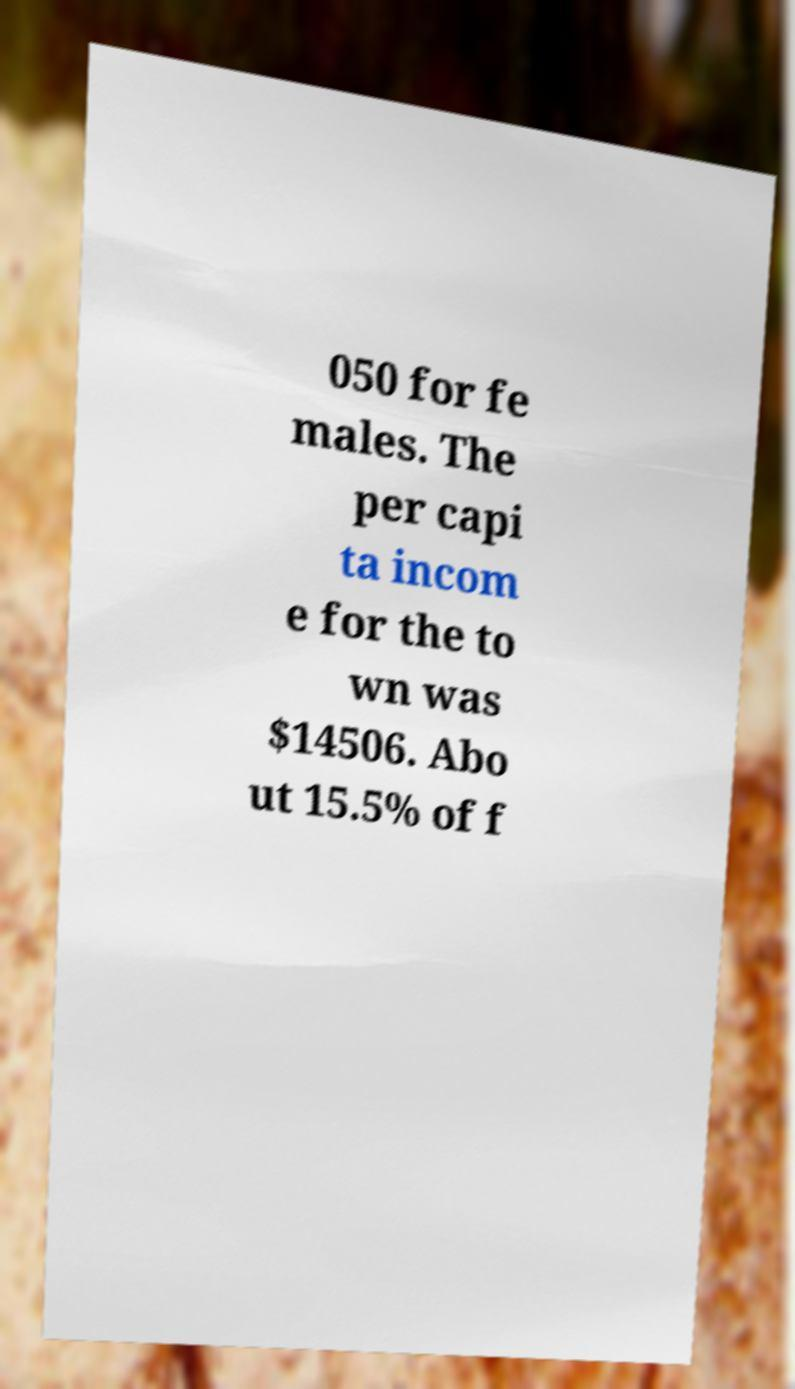I need the written content from this picture converted into text. Can you do that? 050 for fe males. The per capi ta incom e for the to wn was $14506. Abo ut 15.5% of f 